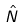<formula> <loc_0><loc_0><loc_500><loc_500>\hat { N }</formula> 